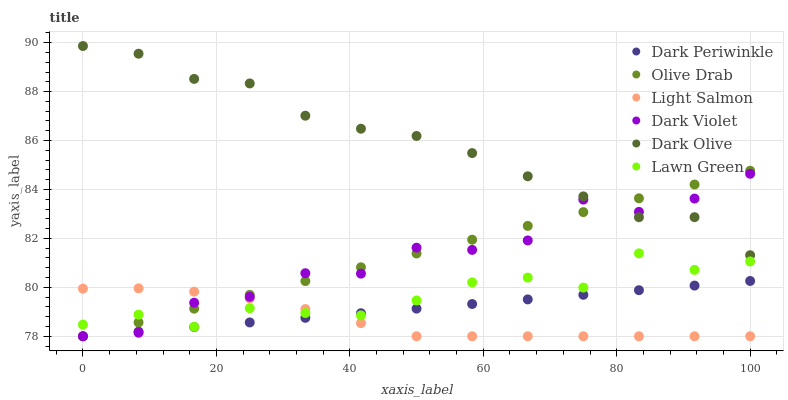Does Light Salmon have the minimum area under the curve?
Answer yes or no. Yes. Does Dark Olive have the maximum area under the curve?
Answer yes or no. Yes. Does Dark Olive have the minimum area under the curve?
Answer yes or no. No. Does Light Salmon have the maximum area under the curve?
Answer yes or no. No. Is Dark Periwinkle the smoothest?
Answer yes or no. Yes. Is Dark Violet the roughest?
Answer yes or no. Yes. Is Light Salmon the smoothest?
Answer yes or no. No. Is Light Salmon the roughest?
Answer yes or no. No. Does Light Salmon have the lowest value?
Answer yes or no. Yes. Does Dark Olive have the lowest value?
Answer yes or no. No. Does Dark Olive have the highest value?
Answer yes or no. Yes. Does Light Salmon have the highest value?
Answer yes or no. No. Is Lawn Green less than Dark Olive?
Answer yes or no. Yes. Is Dark Olive greater than Light Salmon?
Answer yes or no. Yes. Does Olive Drab intersect Dark Olive?
Answer yes or no. Yes. Is Olive Drab less than Dark Olive?
Answer yes or no. No. Is Olive Drab greater than Dark Olive?
Answer yes or no. No. Does Lawn Green intersect Dark Olive?
Answer yes or no. No. 